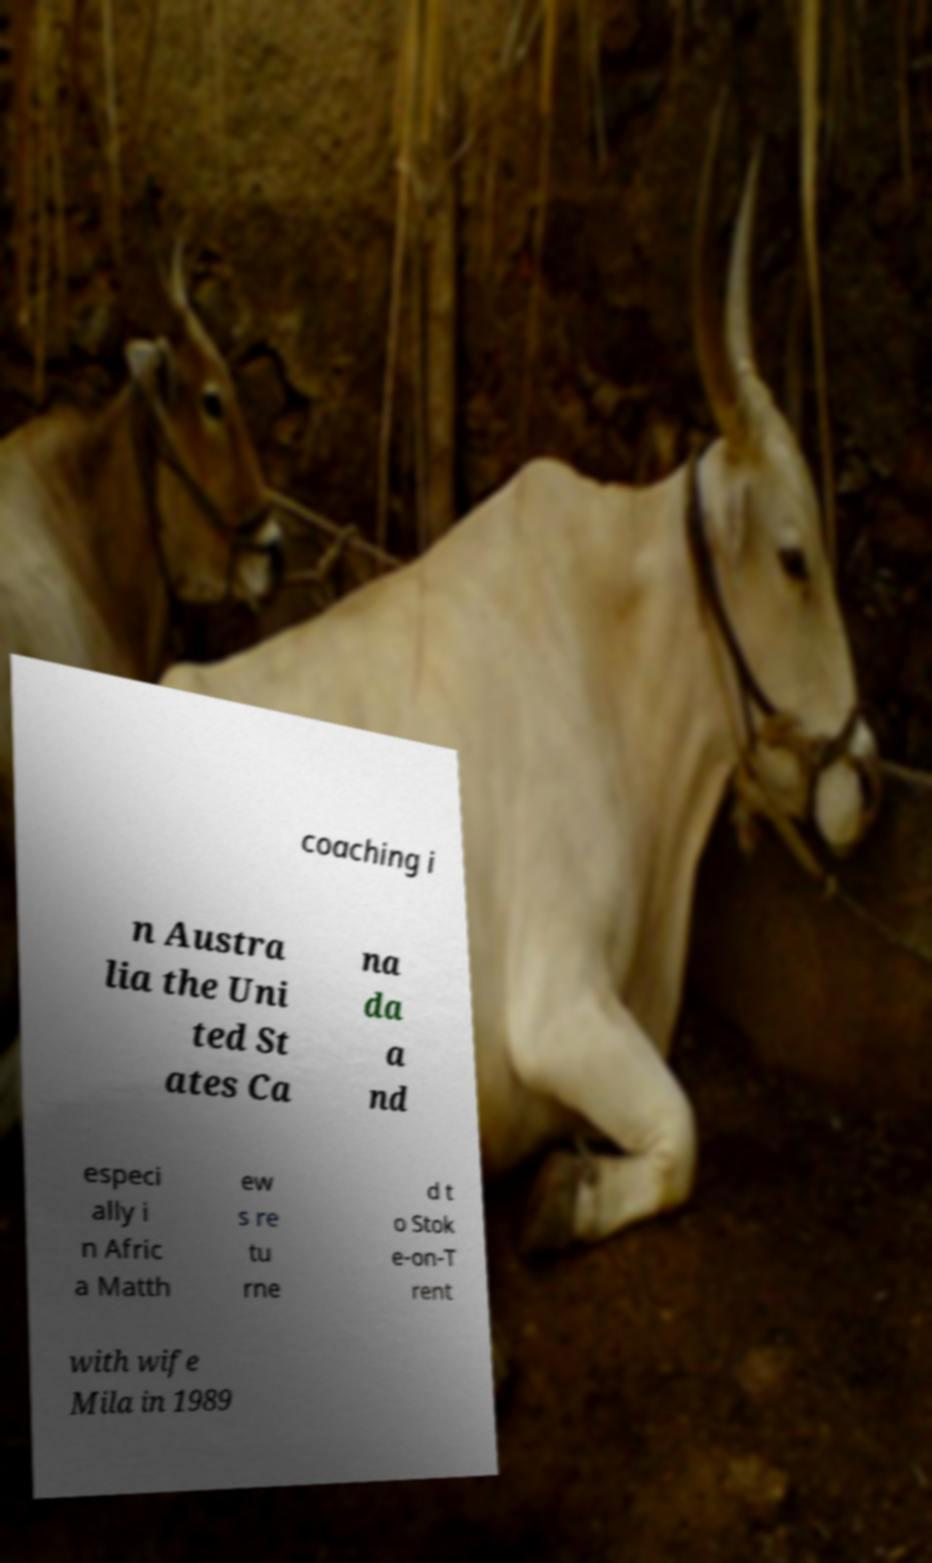Can you accurately transcribe the text from the provided image for me? coaching i n Austra lia the Uni ted St ates Ca na da a nd especi ally i n Afric a Matth ew s re tu rne d t o Stok e-on-T rent with wife Mila in 1989 